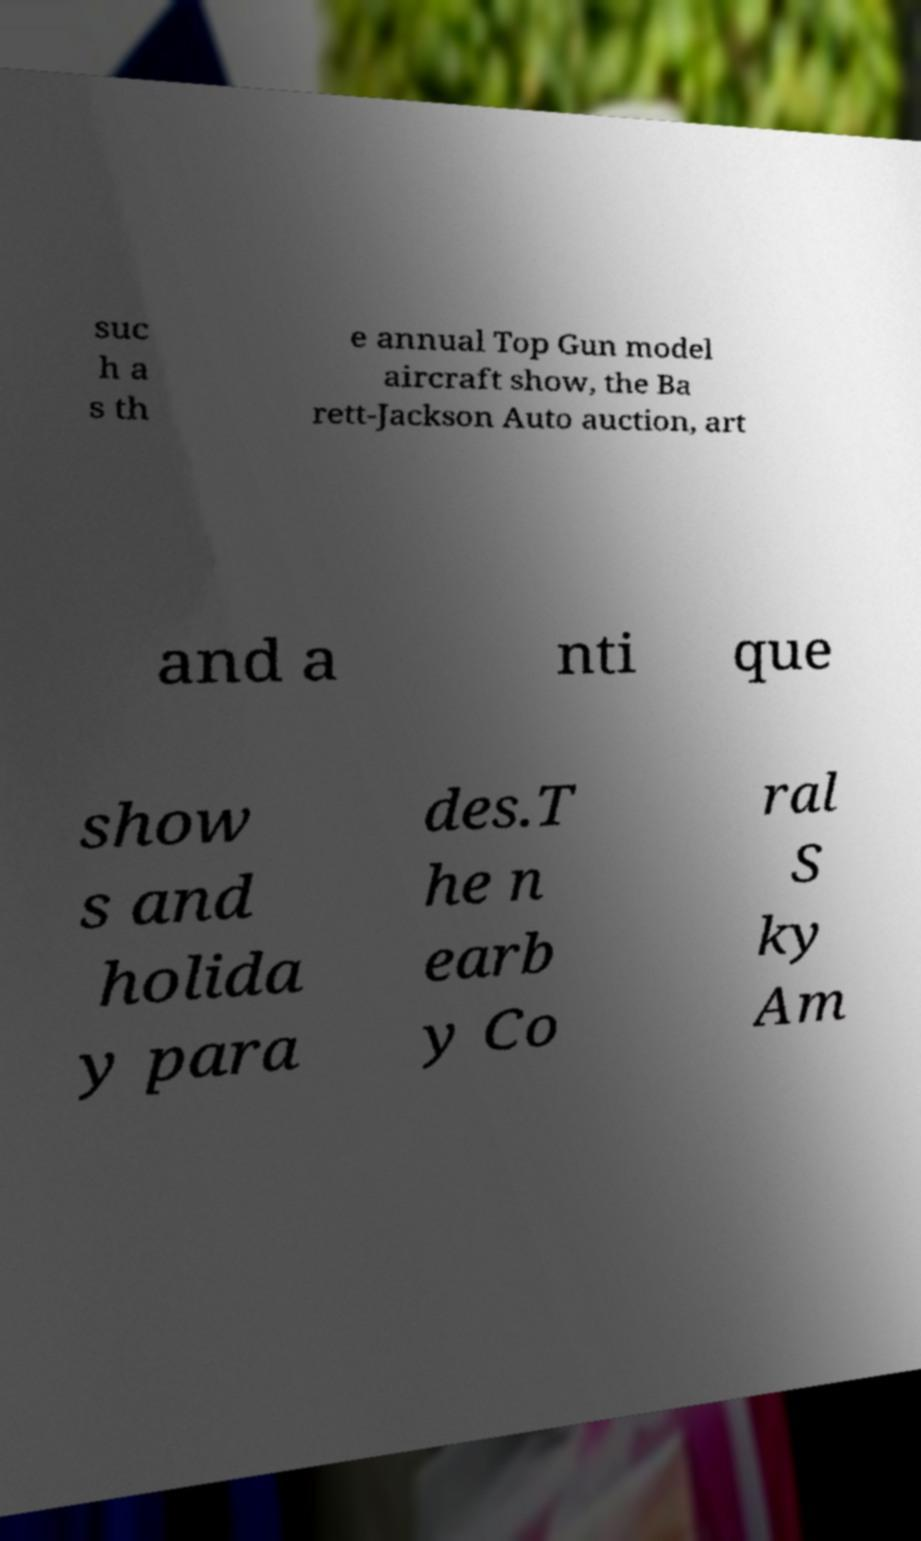Please read and relay the text visible in this image. What does it say? suc h a s th e annual Top Gun model aircraft show, the Ba rett-Jackson Auto auction, art and a nti que show s and holida y para des.T he n earb y Co ral S ky Am 